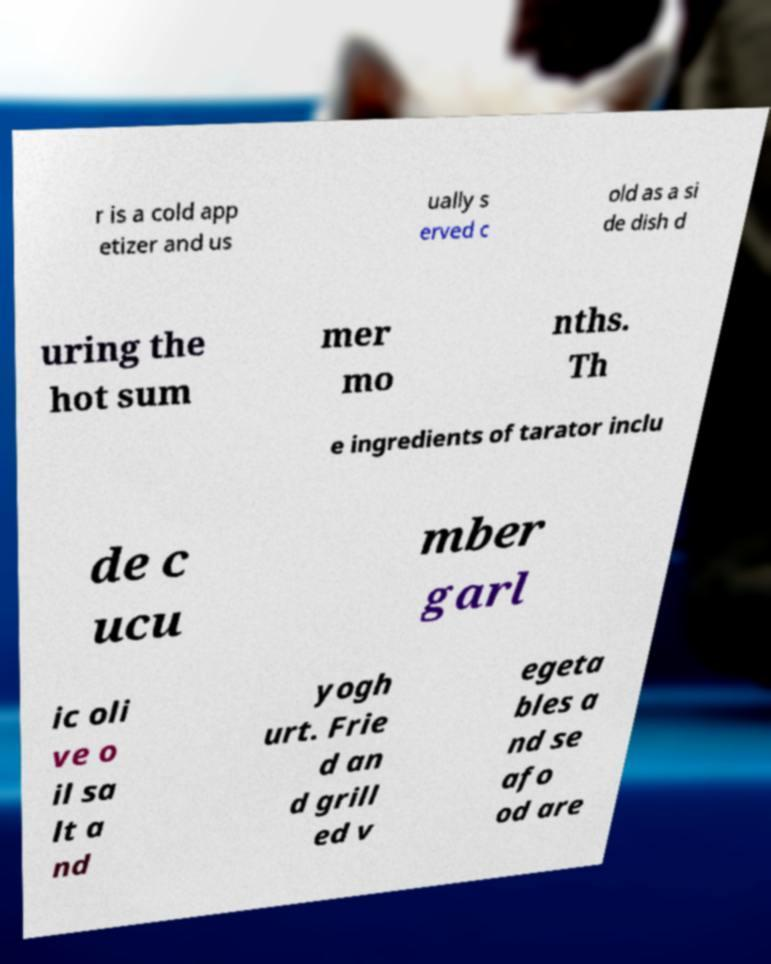Can you accurately transcribe the text from the provided image for me? r is a cold app etizer and us ually s erved c old as a si de dish d uring the hot sum mer mo nths. Th e ingredients of tarator inclu de c ucu mber garl ic oli ve o il sa lt a nd yogh urt. Frie d an d grill ed v egeta bles a nd se afo od are 